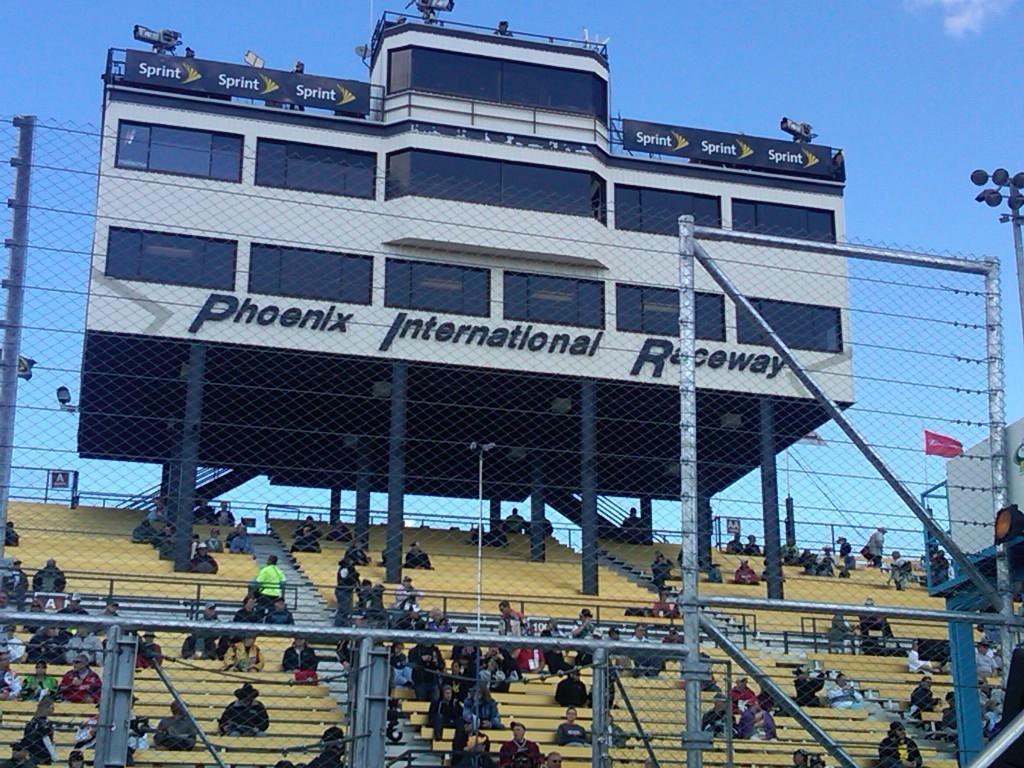Please provide a concise description of this image. There is a mesh fencing with poles. In the back there are many people sitting on the benches. There is a building with windows and pillars. And something is written on the building. In the background there is sky. 